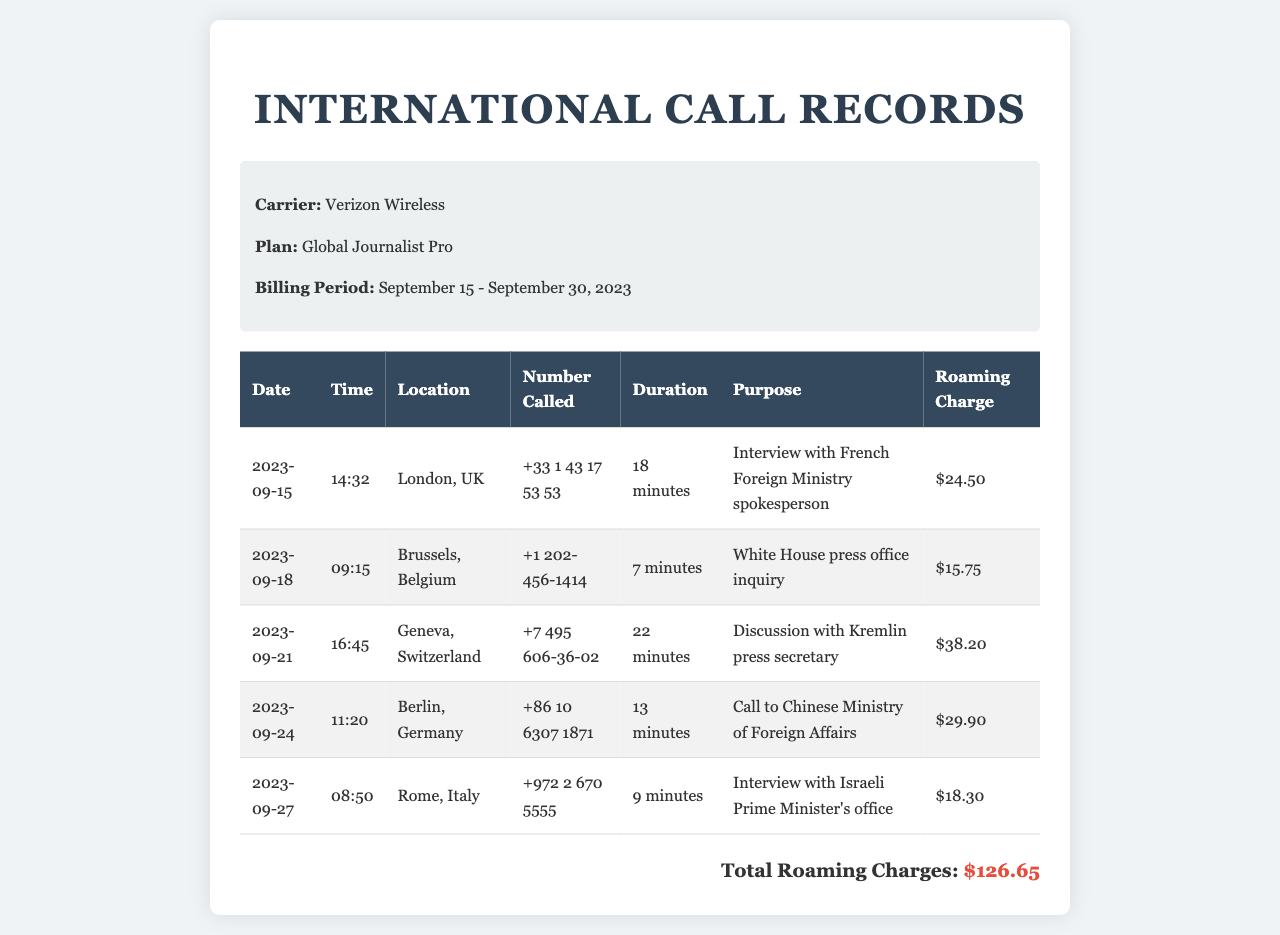What is the carrier? The carrier is listed at the top of the document, indicating the service provider.
Answer: Verizon Wireless What is the billing period? The billing period shows the duration for which the charges are calculated, specified in the document.
Answer: September 15 - September 30, 2023 What was the purpose of the call made on September 21? This purpose can be found in the details of the corresponding call record for that date.
Answer: Discussion with Kremlin press secretary How long was the call to Brussels on September 18? The duration is explicitly stated in the call record for that date and location.
Answer: 7 minutes What is the total roaming charge? The total roaming charge is the sum of all individual roaming charges listed in the table.
Answer: $126.65 Which city was the call to the Chinese Ministry of Foreign Affairs made from? The location is clearly indicated in the corresponding call record.
Answer: Berlin, Germany What time was the call made to the Israeli Prime Minister's office? The time can be pinpointed in the entry specifically about that call made on September 27.
Answer: 08:50 How many minutes was the longest call? The longest duration can be identified by comparing the durations of all calls in the table.
Answer: 22 minutes 